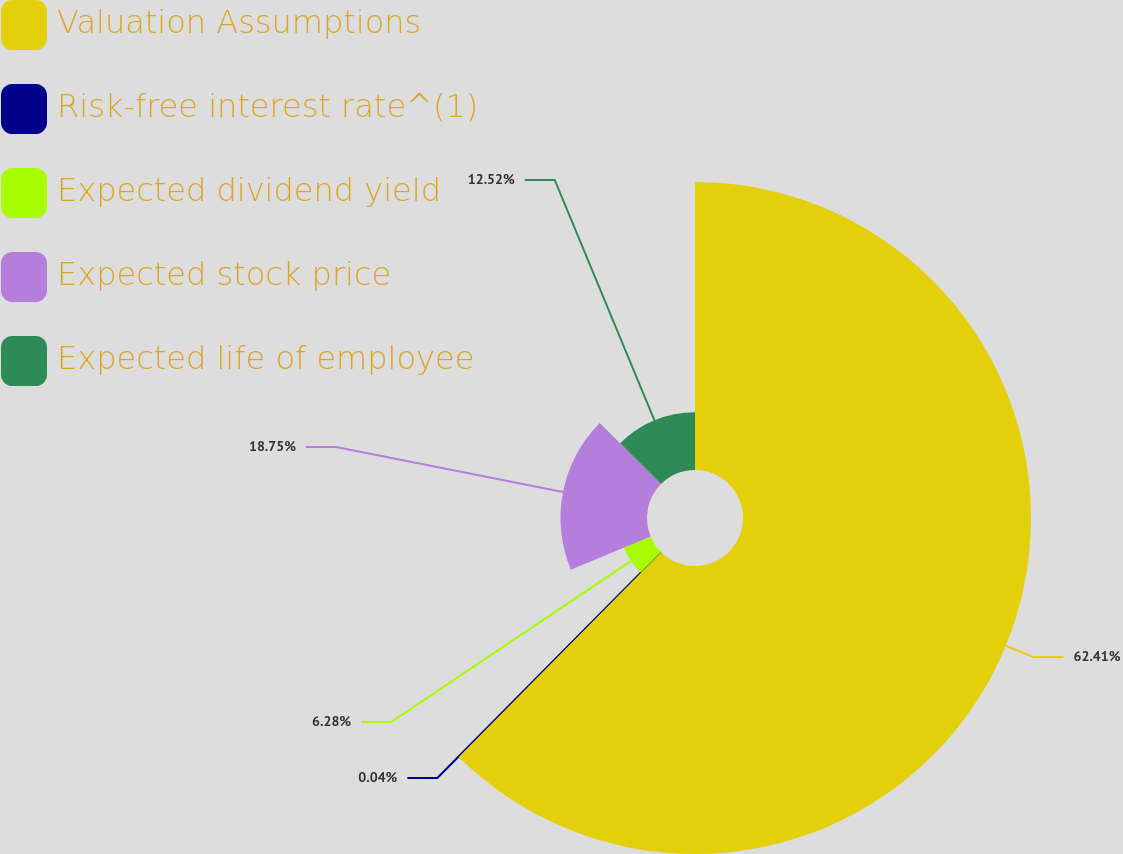Convert chart to OTSL. <chart><loc_0><loc_0><loc_500><loc_500><pie_chart><fcel>Valuation Assumptions<fcel>Risk-free interest rate^(1)<fcel>Expected dividend yield<fcel>Expected stock price<fcel>Expected life of employee<nl><fcel>62.41%<fcel>0.04%<fcel>6.28%<fcel>18.75%<fcel>12.52%<nl></chart> 